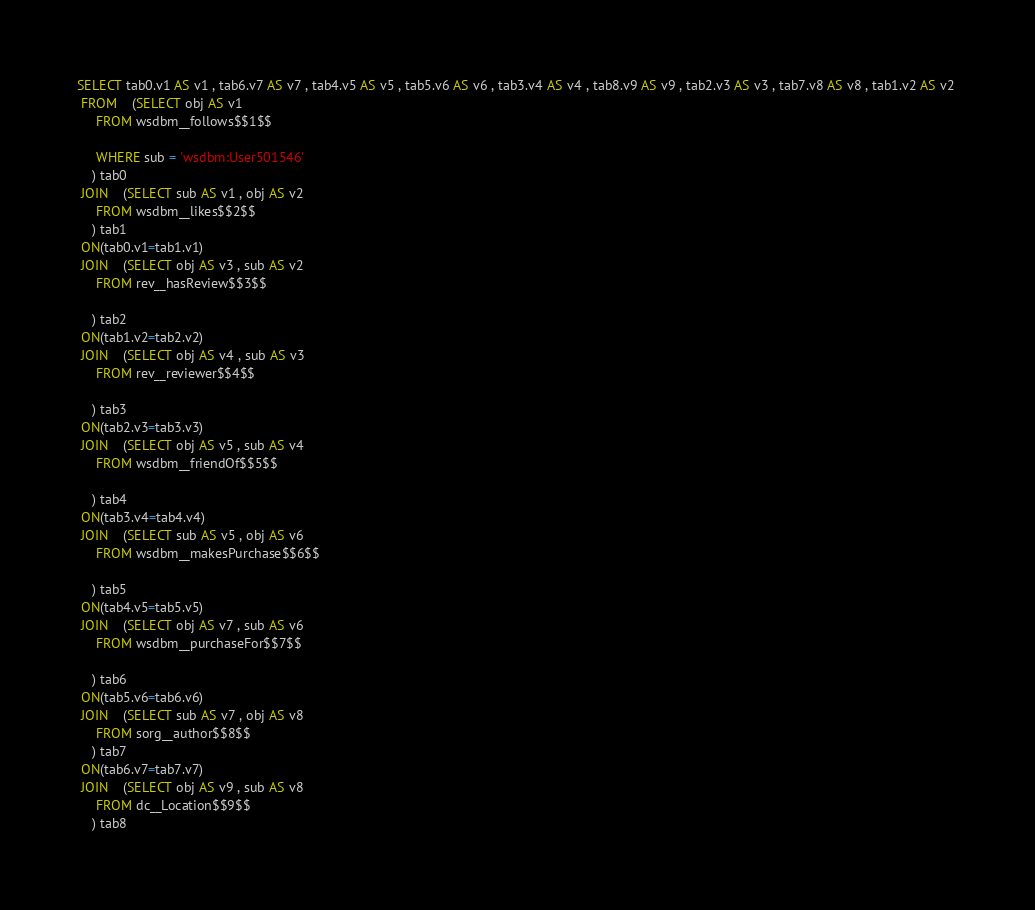<code> <loc_0><loc_0><loc_500><loc_500><_SQL_>SELECT tab0.v1 AS v1 , tab6.v7 AS v7 , tab4.v5 AS v5 , tab5.v6 AS v6 , tab3.v4 AS v4 , tab8.v9 AS v9 , tab2.v3 AS v3 , tab7.v8 AS v8 , tab1.v2 AS v2 
 FROM    (SELECT obj AS v1 
	 FROM wsdbm__follows$$1$$
	 
	 WHERE sub = 'wsdbm:User501546'
	) tab0
 JOIN    (SELECT sub AS v1 , obj AS v2 
	 FROM wsdbm__likes$$2$$
	) tab1
 ON(tab0.v1=tab1.v1)
 JOIN    (SELECT obj AS v3 , sub AS v2 
	 FROM rev__hasReview$$3$$
	
	) tab2
 ON(tab1.v2=tab2.v2)
 JOIN    (SELECT obj AS v4 , sub AS v3 
	 FROM rev__reviewer$$4$$
	
	) tab3
 ON(tab2.v3=tab3.v3)
 JOIN    (SELECT obj AS v5 , sub AS v4 
	 FROM wsdbm__friendOf$$5$$
	
	) tab4
 ON(tab3.v4=tab4.v4)
 JOIN    (SELECT sub AS v5 , obj AS v6 
	 FROM wsdbm__makesPurchase$$6$$
	
	) tab5
 ON(tab4.v5=tab5.v5)
 JOIN    (SELECT obj AS v7 , sub AS v6 
	 FROM wsdbm__purchaseFor$$7$$
	
	) tab6
 ON(tab5.v6=tab6.v6)
 JOIN    (SELECT sub AS v7 , obj AS v8 
	 FROM sorg__author$$8$$
	) tab7
 ON(tab6.v7=tab7.v7)
 JOIN    (SELECT obj AS v9 , sub AS v8 
	 FROM dc__Location$$9$$
	) tab8</code> 